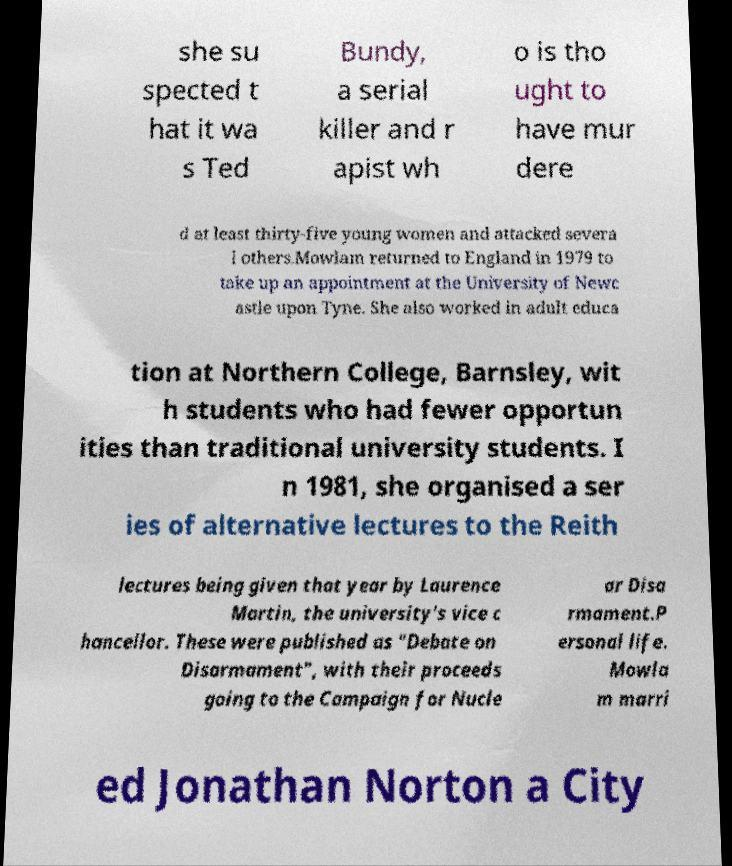What messages or text are displayed in this image? I need them in a readable, typed format. she su spected t hat it wa s Ted Bundy, a serial killer and r apist wh o is tho ught to have mur dere d at least thirty-five young women and attacked severa l others.Mowlam returned to England in 1979 to take up an appointment at the University of Newc astle upon Tyne. She also worked in adult educa tion at Northern College, Barnsley, wit h students who had fewer opportun ities than traditional university students. I n 1981, she organised a ser ies of alternative lectures to the Reith lectures being given that year by Laurence Martin, the university's vice c hancellor. These were published as "Debate on Disarmament", with their proceeds going to the Campaign for Nucle ar Disa rmament.P ersonal life. Mowla m marri ed Jonathan Norton a City 